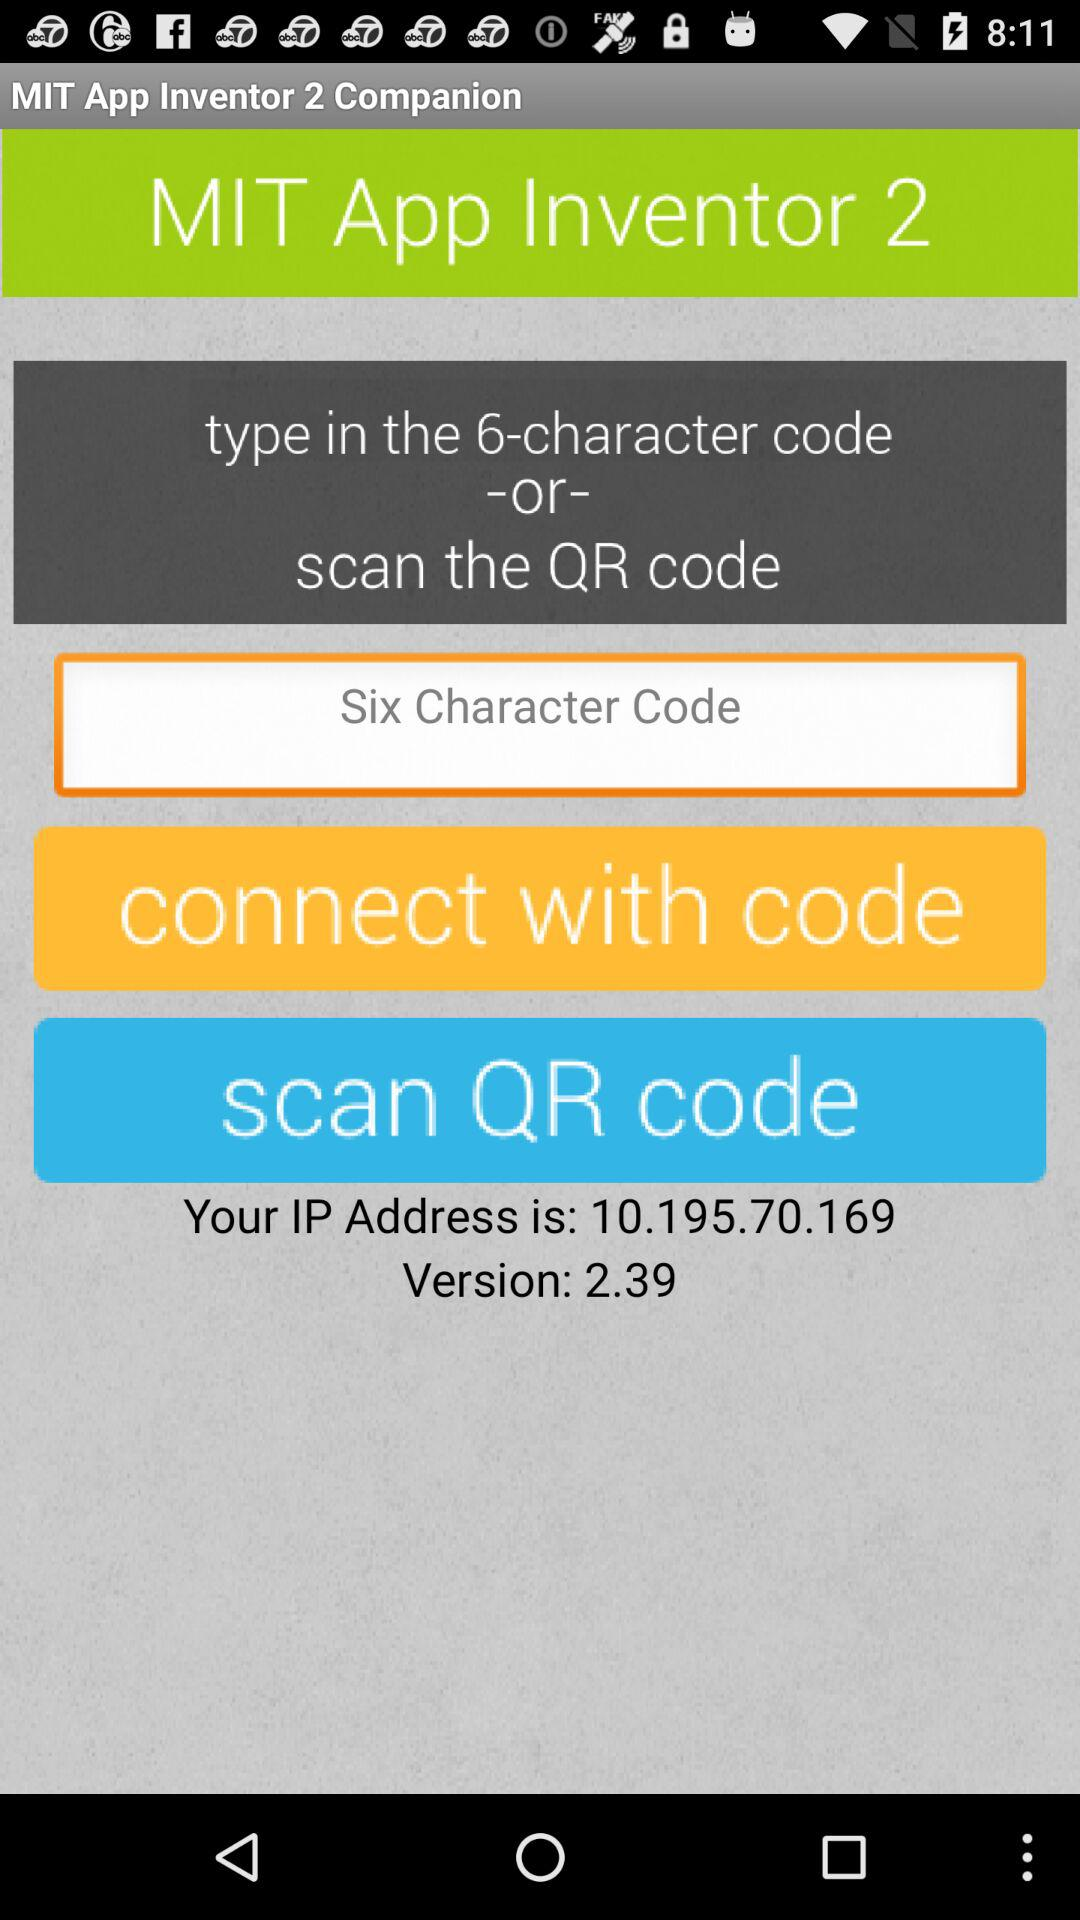What is the given IP address? The given IP address is 10.195.70.169. 